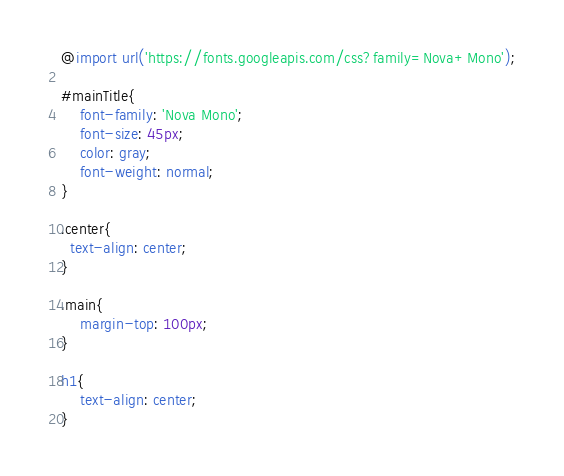<code> <loc_0><loc_0><loc_500><loc_500><_CSS_>@import url('https://fonts.googleapis.com/css?family=Nova+Mono');

#mainTitle{
    font-family: 'Nova Mono';
    font-size: 45px;
    color: gray;
    font-weight: normal;
}

.center{
  text-align: center;
}

.main{
    margin-top: 100px;
}

h1{
    text-align: center;
}
</code> 